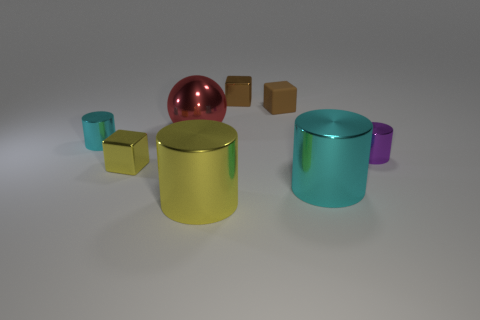Do the brown block behind the tiny matte thing and the small cyan thing have the same material?
Ensure brevity in your answer.  Yes. Is the number of red shiny objects that are in front of the tiny yellow thing the same as the number of small cyan cylinders that are behind the tiny brown rubber thing?
Give a very brief answer. Yes. There is a metal object behind the red thing; what size is it?
Your response must be concise. Small. Are there any tiny gray objects that have the same material as the purple thing?
Provide a short and direct response. No. There is a small metallic thing behind the big red sphere; does it have the same color as the big shiny sphere?
Your answer should be compact. No. Are there an equal number of yellow objects that are to the left of the big sphere and big balls?
Your answer should be compact. Yes. Are there any other metallic spheres that have the same color as the metal sphere?
Make the answer very short. No. Does the matte thing have the same size as the purple thing?
Keep it short and to the point. Yes. How big is the cylinder in front of the cyan metal thing that is on the right side of the big sphere?
Offer a very short reply. Large. There is a shiny object that is both behind the small cyan metallic thing and in front of the rubber block; what is its size?
Your answer should be very brief. Large. 